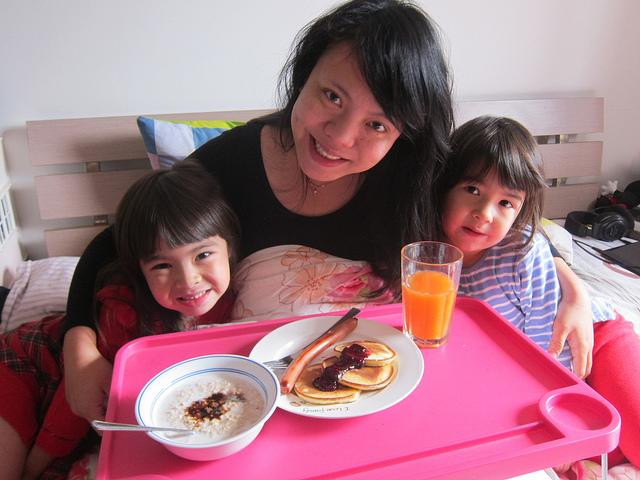How do these people know each other? Please explain your reasoning. family. The woman has two daughters and they all resemble each other. 